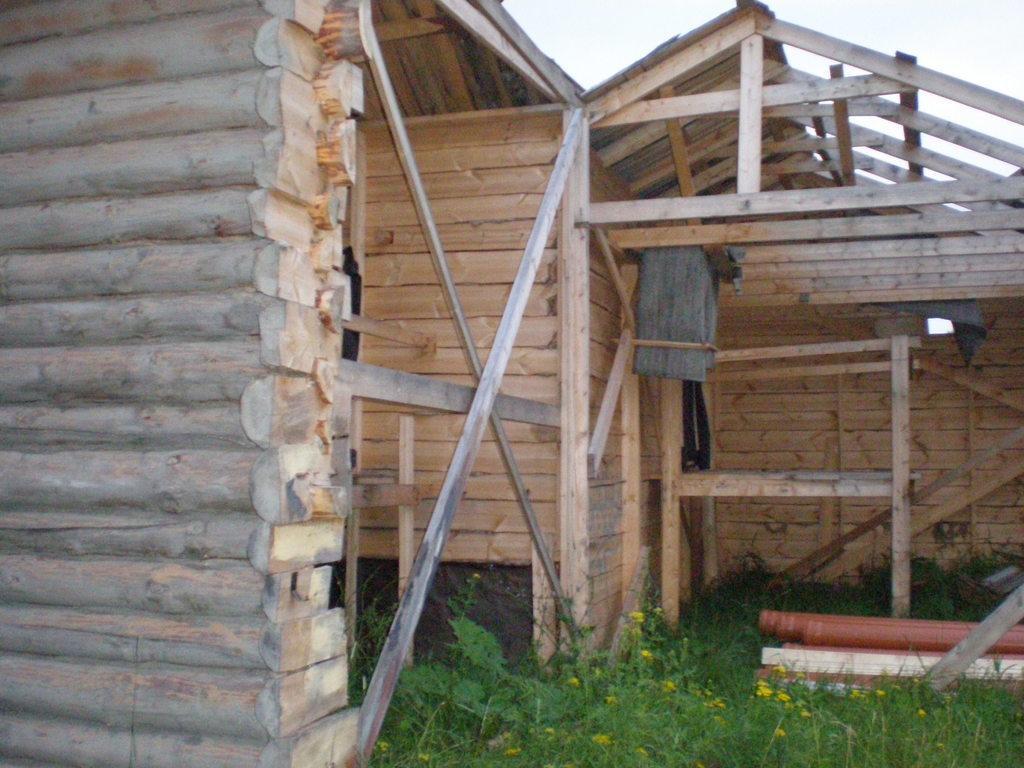Please provide a concise description of this image. In the foreground of this image, on the bottom, there is the grass. In the middle, there is construction of wooden house. On the top, there is the sky. 